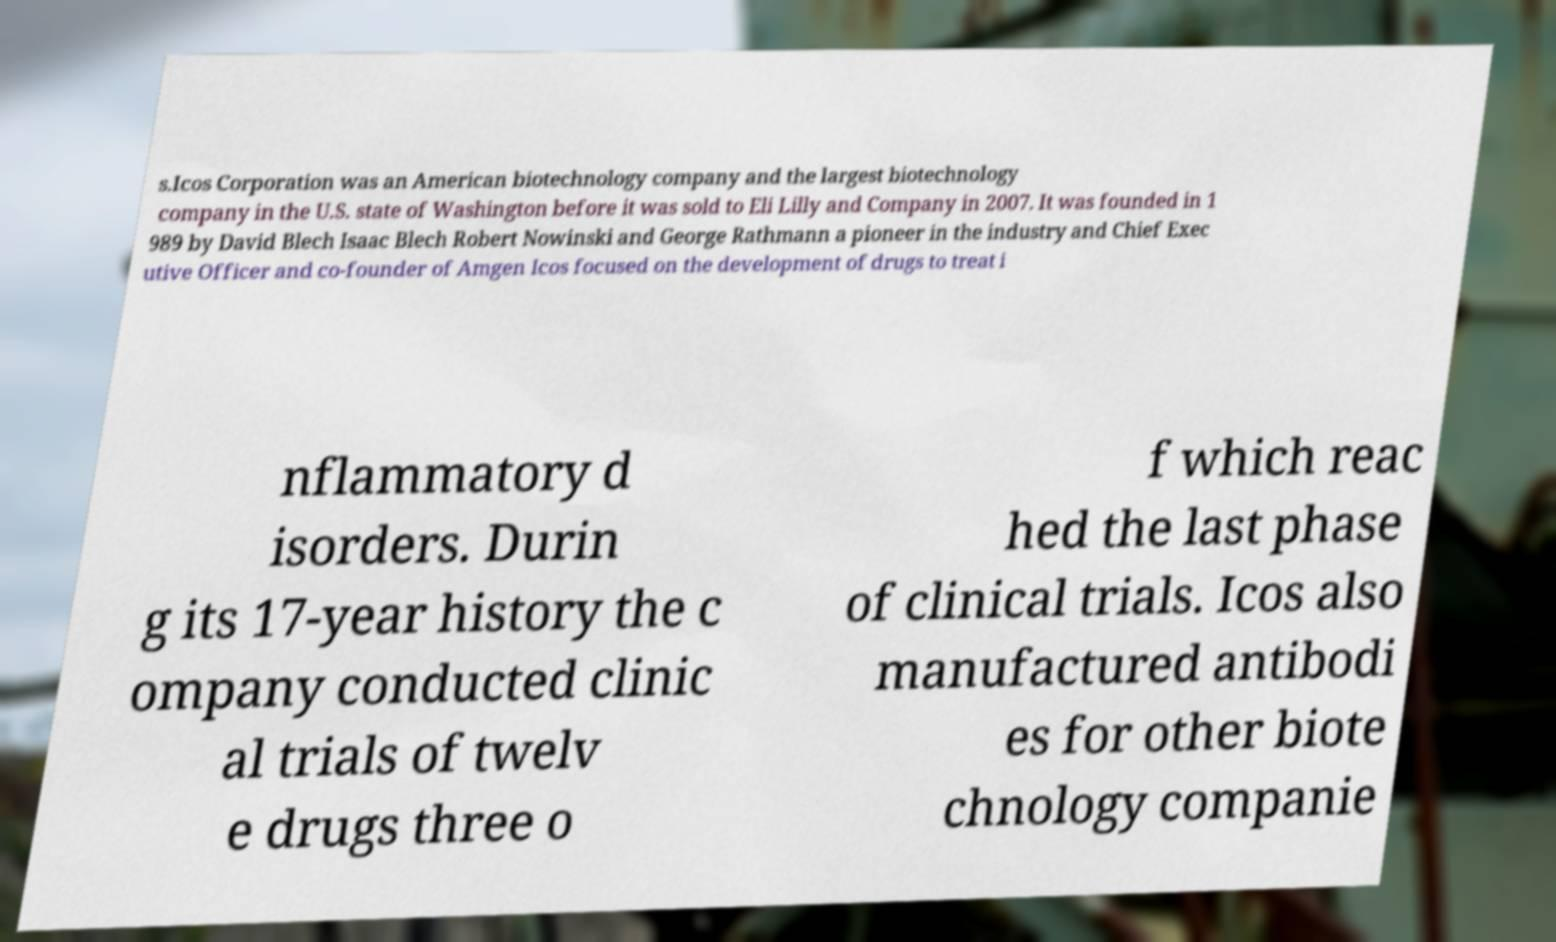Can you read and provide the text displayed in the image?This photo seems to have some interesting text. Can you extract and type it out for me? s.Icos Corporation was an American biotechnology company and the largest biotechnology company in the U.S. state of Washington before it was sold to Eli Lilly and Company in 2007. It was founded in 1 989 by David Blech Isaac Blech Robert Nowinski and George Rathmann a pioneer in the industry and Chief Exec utive Officer and co-founder of Amgen Icos focused on the development of drugs to treat i nflammatory d isorders. Durin g its 17-year history the c ompany conducted clinic al trials of twelv e drugs three o f which reac hed the last phase of clinical trials. Icos also manufactured antibodi es for other biote chnology companie 